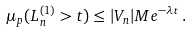Convert formula to latex. <formula><loc_0><loc_0><loc_500><loc_500>\mu _ { p } ( L _ { n } ^ { ( 1 ) } > t ) \leq | V _ { n } | M e ^ { - \lambda t } \, .</formula> 